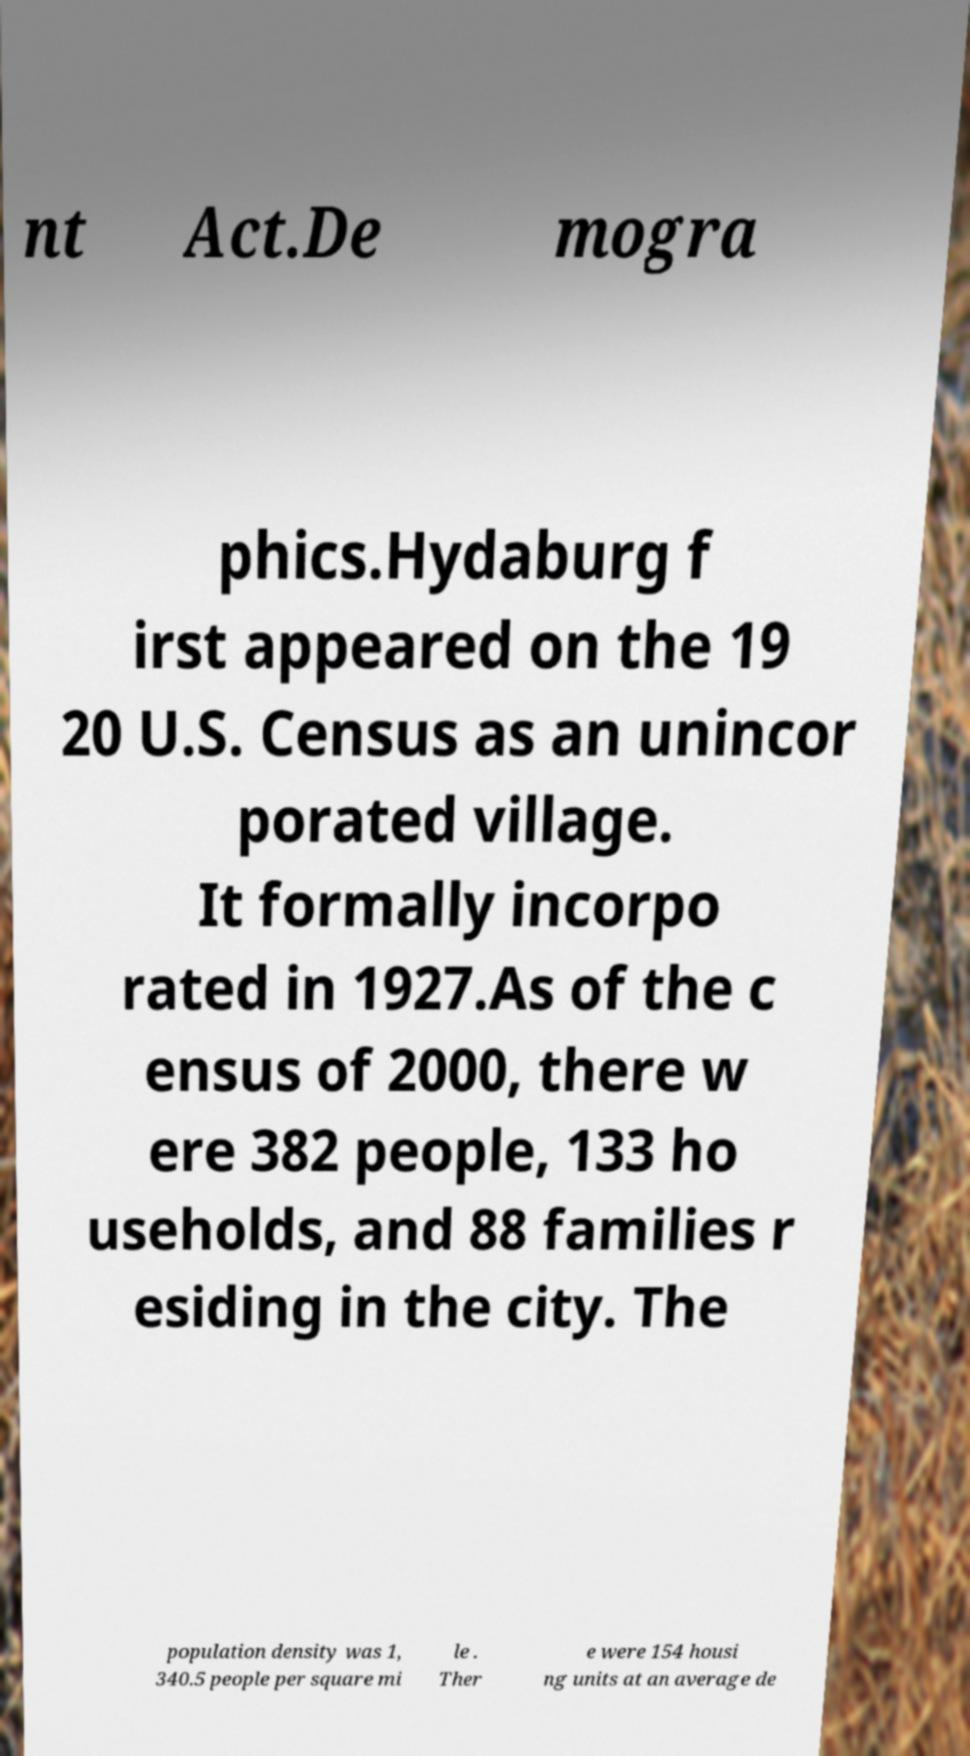What messages or text are displayed in this image? I need them in a readable, typed format. nt Act.De mogra phics.Hydaburg f irst appeared on the 19 20 U.S. Census as an unincor porated village. It formally incorpo rated in 1927.As of the c ensus of 2000, there w ere 382 people, 133 ho useholds, and 88 families r esiding in the city. The population density was 1, 340.5 people per square mi le . Ther e were 154 housi ng units at an average de 